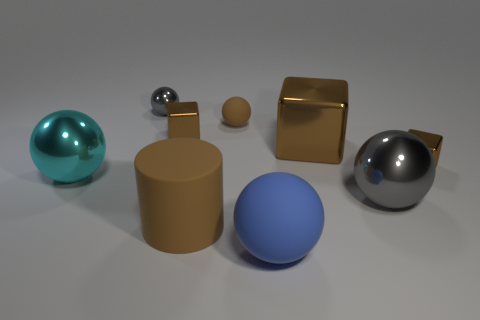Is the big matte cylinder the same color as the big metal block?
Your answer should be compact. Yes. Are there any other large spheres of the same color as the big rubber sphere?
Make the answer very short. No. The other rubber thing that is the same size as the blue rubber thing is what shape?
Give a very brief answer. Cylinder. Is the number of tiny green rubber cylinders less than the number of big cyan shiny spheres?
Offer a very short reply. Yes. What number of brown rubber cylinders are the same size as the cyan object?
Ensure brevity in your answer.  1. The tiny matte thing that is the same color as the large metallic block is what shape?
Ensure brevity in your answer.  Sphere. What material is the big cyan ball?
Give a very brief answer. Metal. How big is the block left of the big blue thing?
Provide a short and direct response. Small. How many gray things are the same shape as the blue thing?
Your answer should be very brief. 2. What is the shape of the small brown object that is made of the same material as the large blue ball?
Offer a very short reply. Sphere. 